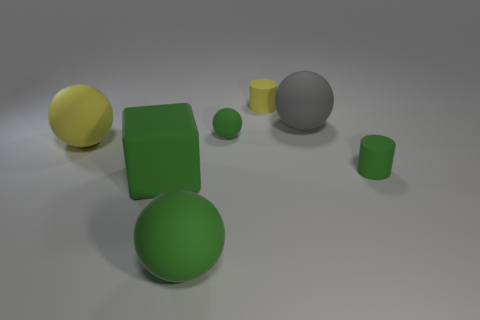Add 1 large gray objects. How many objects exist? 8 Subtract all blocks. How many objects are left? 6 Subtract 0 cyan spheres. How many objects are left? 7 Subtract all small green matte cylinders. Subtract all small spheres. How many objects are left? 5 Add 5 green blocks. How many green blocks are left? 6 Add 5 matte spheres. How many matte spheres exist? 9 